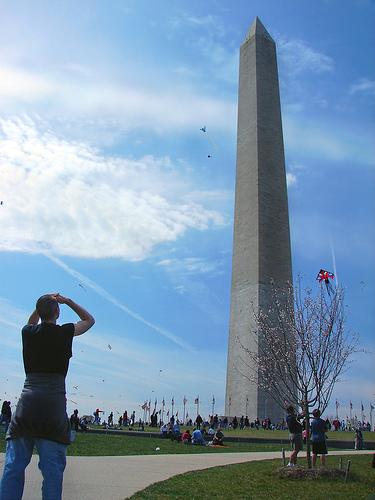Are there clouds visible?
Be succinct. Yes. What is flying in the sky?
Short answer required. Kite. Where is this picture taken?
Quick response, please. Washington dc. 